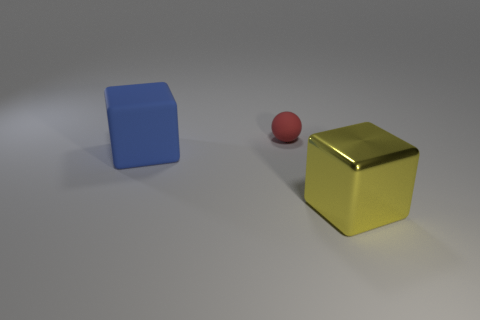Add 1 tiny yellow cubes. How many objects exist? 4 Subtract all balls. How many objects are left? 2 Add 2 tiny yellow cylinders. How many tiny yellow cylinders exist? 2 Subtract 0 red cylinders. How many objects are left? 3 Subtract all large blue objects. Subtract all matte things. How many objects are left? 0 Add 2 big yellow shiny blocks. How many big yellow shiny blocks are left? 3 